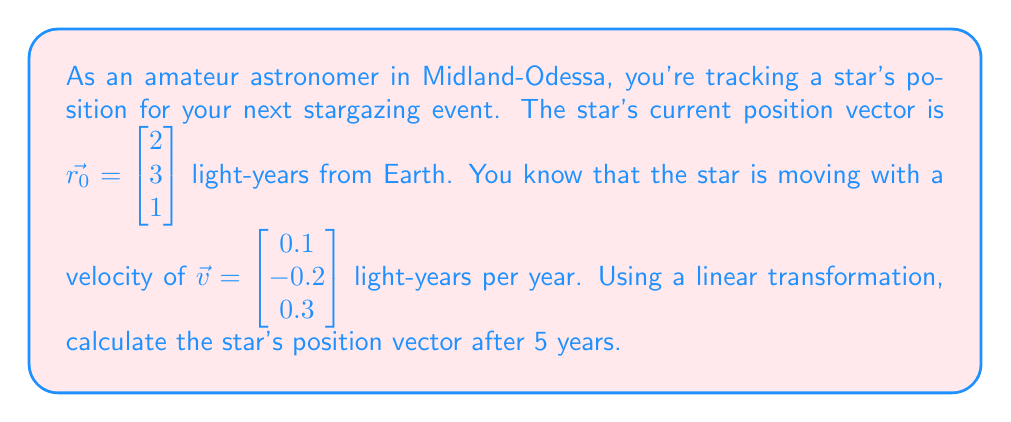Can you answer this question? To solve this problem, we need to use the concept of linear transformations in the context of stellar motion. The star's motion can be described as a linear transformation of its initial position over time.

1) The general equation for the position of an object moving with constant velocity is:

   $$\vec{r}(t) = \vec{r_0} + t\vec{v}$$

   where $\vec{r}(t)$ is the position vector at time $t$, $\vec{r_0}$ is the initial position vector, and $\vec{v}$ is the velocity vector.

2) In this case, we have:
   
   $\vec{r_0} = \begin{bmatrix} 2 \\ 3 \\ 1 \end{bmatrix}$
   
   $\vec{v} = \begin{bmatrix} 0.1 \\ -0.2 \\ 0.3 \end{bmatrix}$
   
   $t = 5$ years

3) We can represent this transformation as a matrix operation:

   $$\vec{r}(5) = \begin{bmatrix} 2 \\ 3 \\ 1 \end{bmatrix} + 5\begin{bmatrix} 0.1 \\ -0.2 \\ 0.3 \end{bmatrix}$$

4) Let's calculate the second term:

   $$5\begin{bmatrix} 0.1 \\ -0.2 \\ 0.3 \end{bmatrix} = \begin{bmatrix} 0.5 \\ -1 \\ 1.5 \end{bmatrix}$$

5) Now, we can add this to the initial position vector:

   $$\vec{r}(5) = \begin{bmatrix} 2 \\ 3 \\ 1 \end{bmatrix} + \begin{bmatrix} 0.5 \\ -1 \\ 1.5 \end{bmatrix} = \begin{bmatrix} 2.5 \\ 2 \\ 2.5 \end{bmatrix}$$

Therefore, after 5 years, the star's position vector will be $\begin{bmatrix} 2.5 \\ 2 \\ 2.5 \end{bmatrix}$ light-years from Earth.
Answer: $\vec{r}(5) = \begin{bmatrix} 2.5 \\ 2 \\ 2.5 \end{bmatrix}$ light-years 